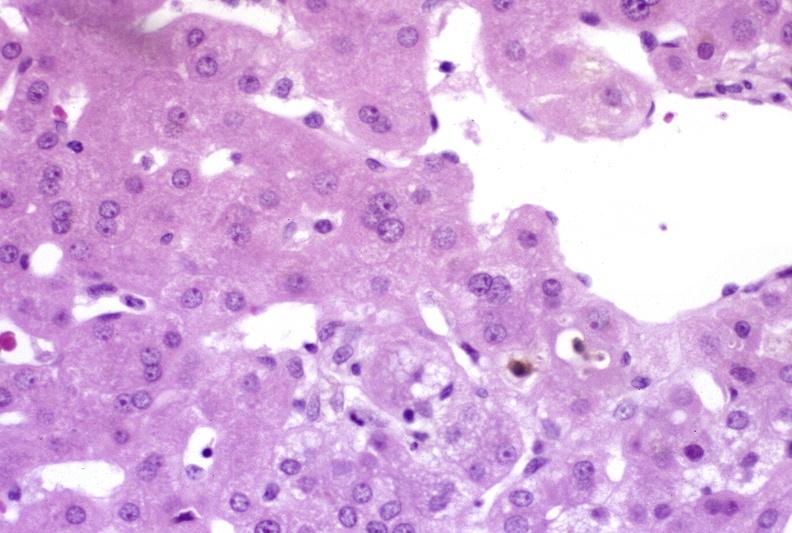s anencephaly and bilateral cleft palate present?
Answer the question using a single word or phrase. No 